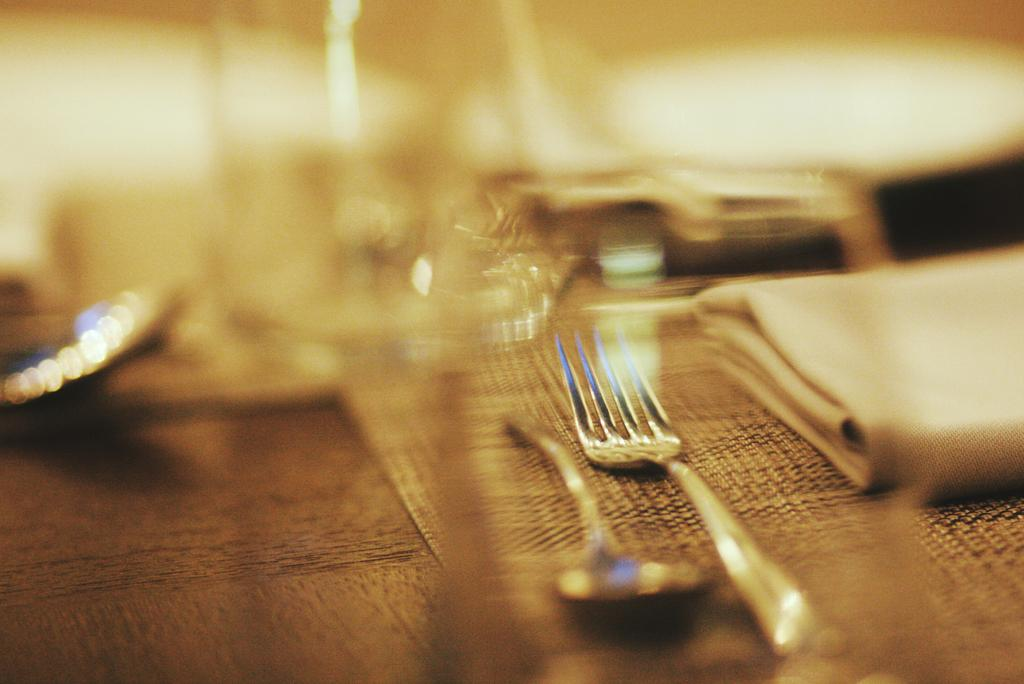What utensils can be seen in the image? There is a spoon and a fork in the image. What item might be used for cleaning or wiping in the image? There is a napkin in the image for cleaning or wiping. What surface is visible in the image? There is a wooden surface in the image. What is placed beneath the wooden surface? There is a mat in the image. What can be observed about the top of the image? The top of the image has a blurry view. What type of scarecrow can be seen in the image? There is no scarecrow present in the image. What event might have caused the blurry view at the top of the image? The blurry view at the top of the image is not caused by any specific event; it is simply a characteristic of the image. 